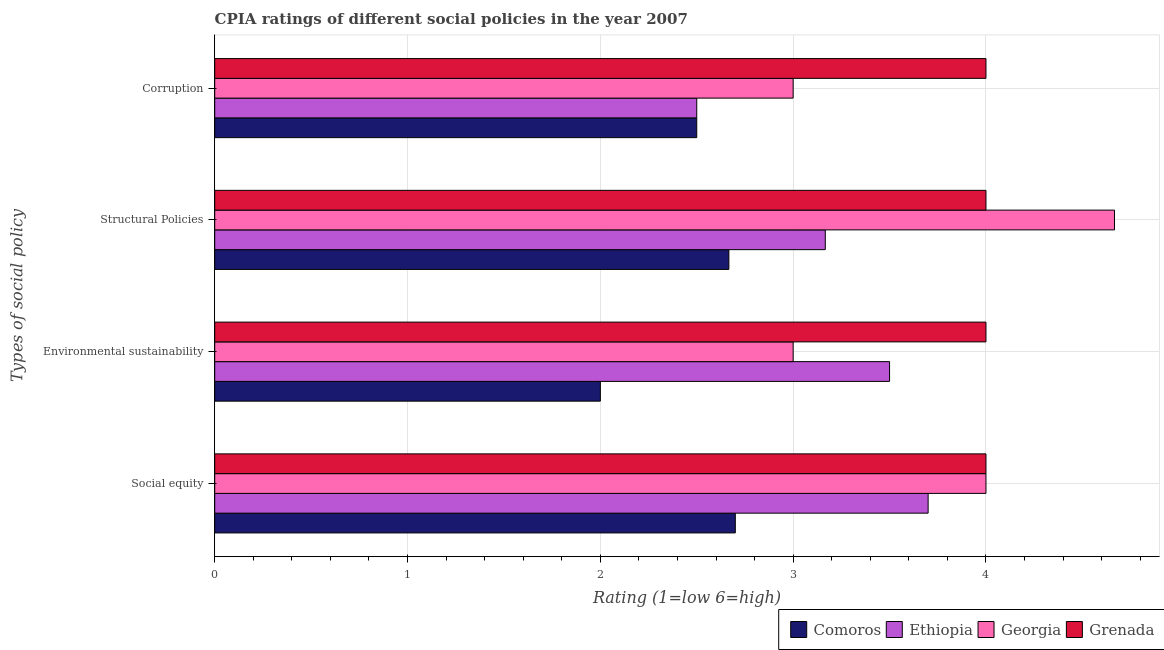How many groups of bars are there?
Ensure brevity in your answer.  4. Are the number of bars per tick equal to the number of legend labels?
Your answer should be very brief. Yes. Are the number of bars on each tick of the Y-axis equal?
Keep it short and to the point. Yes. What is the label of the 2nd group of bars from the top?
Keep it short and to the point. Structural Policies. What is the cpia rating of environmental sustainability in Georgia?
Your answer should be compact. 3. Across all countries, what is the maximum cpia rating of structural policies?
Give a very brief answer. 4.67. Across all countries, what is the minimum cpia rating of social equity?
Offer a very short reply. 2.7. In which country was the cpia rating of environmental sustainability maximum?
Provide a succinct answer. Grenada. In which country was the cpia rating of social equity minimum?
Provide a succinct answer. Comoros. What is the total cpia rating of corruption in the graph?
Ensure brevity in your answer.  12. What is the difference between the cpia rating of corruption in Comoros and the cpia rating of social equity in Georgia?
Your answer should be very brief. -1.5. What is the average cpia rating of social equity per country?
Offer a terse response. 3.6. What is the difference between the cpia rating of social equity and cpia rating of corruption in Comoros?
Give a very brief answer. 0.2. What is the ratio of the cpia rating of environmental sustainability in Grenada to that in Ethiopia?
Keep it short and to the point. 1.14. Is the cpia rating of corruption in Georgia less than that in Grenada?
Your response must be concise. Yes. Is the difference between the cpia rating of structural policies in Georgia and Ethiopia greater than the difference between the cpia rating of corruption in Georgia and Ethiopia?
Your answer should be compact. Yes. What is the difference between the highest and the second highest cpia rating of corruption?
Your answer should be compact. 1. What is the difference between the highest and the lowest cpia rating of environmental sustainability?
Provide a short and direct response. 2. Is the sum of the cpia rating of environmental sustainability in Grenada and Ethiopia greater than the maximum cpia rating of corruption across all countries?
Make the answer very short. Yes. Is it the case that in every country, the sum of the cpia rating of structural policies and cpia rating of corruption is greater than the sum of cpia rating of environmental sustainability and cpia rating of social equity?
Offer a very short reply. No. What does the 1st bar from the top in Corruption represents?
Offer a terse response. Grenada. What does the 1st bar from the bottom in Corruption represents?
Your response must be concise. Comoros. Is it the case that in every country, the sum of the cpia rating of social equity and cpia rating of environmental sustainability is greater than the cpia rating of structural policies?
Your answer should be compact. Yes. How many bars are there?
Offer a terse response. 16. How many countries are there in the graph?
Provide a succinct answer. 4. Are the values on the major ticks of X-axis written in scientific E-notation?
Your answer should be very brief. No. Does the graph contain grids?
Make the answer very short. Yes. Where does the legend appear in the graph?
Keep it short and to the point. Bottom right. How are the legend labels stacked?
Your answer should be very brief. Horizontal. What is the title of the graph?
Your answer should be compact. CPIA ratings of different social policies in the year 2007. What is the label or title of the Y-axis?
Provide a short and direct response. Types of social policy. What is the Rating (1=low 6=high) in Comoros in Social equity?
Ensure brevity in your answer.  2.7. What is the Rating (1=low 6=high) of Grenada in Social equity?
Provide a succinct answer. 4. What is the Rating (1=low 6=high) of Comoros in Environmental sustainability?
Give a very brief answer. 2. What is the Rating (1=low 6=high) in Comoros in Structural Policies?
Offer a very short reply. 2.67. What is the Rating (1=low 6=high) of Ethiopia in Structural Policies?
Give a very brief answer. 3.17. What is the Rating (1=low 6=high) in Georgia in Structural Policies?
Ensure brevity in your answer.  4.67. What is the Rating (1=low 6=high) of Grenada in Structural Policies?
Keep it short and to the point. 4. What is the Rating (1=low 6=high) in Comoros in Corruption?
Your answer should be compact. 2.5. What is the Rating (1=low 6=high) of Grenada in Corruption?
Make the answer very short. 4. Across all Types of social policy, what is the maximum Rating (1=low 6=high) in Comoros?
Offer a very short reply. 2.7. Across all Types of social policy, what is the maximum Rating (1=low 6=high) in Georgia?
Provide a succinct answer. 4.67. Across all Types of social policy, what is the minimum Rating (1=low 6=high) of Ethiopia?
Your response must be concise. 2.5. Across all Types of social policy, what is the minimum Rating (1=low 6=high) in Grenada?
Your answer should be very brief. 4. What is the total Rating (1=low 6=high) in Comoros in the graph?
Your answer should be very brief. 9.87. What is the total Rating (1=low 6=high) in Ethiopia in the graph?
Give a very brief answer. 12.87. What is the total Rating (1=low 6=high) in Georgia in the graph?
Ensure brevity in your answer.  14.67. What is the total Rating (1=low 6=high) of Grenada in the graph?
Your response must be concise. 16. What is the difference between the Rating (1=low 6=high) of Comoros in Social equity and that in Environmental sustainability?
Keep it short and to the point. 0.7. What is the difference between the Rating (1=low 6=high) of Grenada in Social equity and that in Environmental sustainability?
Your response must be concise. 0. What is the difference between the Rating (1=low 6=high) in Comoros in Social equity and that in Structural Policies?
Your answer should be compact. 0.03. What is the difference between the Rating (1=low 6=high) in Ethiopia in Social equity and that in Structural Policies?
Your answer should be very brief. 0.53. What is the difference between the Rating (1=low 6=high) in Georgia in Social equity and that in Structural Policies?
Make the answer very short. -0.67. What is the difference between the Rating (1=low 6=high) in Grenada in Social equity and that in Structural Policies?
Your answer should be compact. 0. What is the difference between the Rating (1=low 6=high) of Ethiopia in Social equity and that in Corruption?
Ensure brevity in your answer.  1.2. What is the difference between the Rating (1=low 6=high) of Georgia in Social equity and that in Corruption?
Give a very brief answer. 1. What is the difference between the Rating (1=low 6=high) in Georgia in Environmental sustainability and that in Structural Policies?
Your answer should be very brief. -1.67. What is the difference between the Rating (1=low 6=high) in Comoros in Environmental sustainability and that in Corruption?
Provide a succinct answer. -0.5. What is the difference between the Rating (1=low 6=high) in Ethiopia in Environmental sustainability and that in Corruption?
Your response must be concise. 1. What is the difference between the Rating (1=low 6=high) of Grenada in Environmental sustainability and that in Corruption?
Your answer should be very brief. 0. What is the difference between the Rating (1=low 6=high) of Comoros in Social equity and the Rating (1=low 6=high) of Ethiopia in Environmental sustainability?
Your response must be concise. -0.8. What is the difference between the Rating (1=low 6=high) in Comoros in Social equity and the Rating (1=low 6=high) in Grenada in Environmental sustainability?
Make the answer very short. -1.3. What is the difference between the Rating (1=low 6=high) in Ethiopia in Social equity and the Rating (1=low 6=high) in Georgia in Environmental sustainability?
Offer a very short reply. 0.7. What is the difference between the Rating (1=low 6=high) of Ethiopia in Social equity and the Rating (1=low 6=high) of Grenada in Environmental sustainability?
Your response must be concise. -0.3. What is the difference between the Rating (1=low 6=high) in Comoros in Social equity and the Rating (1=low 6=high) in Ethiopia in Structural Policies?
Provide a succinct answer. -0.47. What is the difference between the Rating (1=low 6=high) of Comoros in Social equity and the Rating (1=low 6=high) of Georgia in Structural Policies?
Make the answer very short. -1.97. What is the difference between the Rating (1=low 6=high) of Ethiopia in Social equity and the Rating (1=low 6=high) of Georgia in Structural Policies?
Ensure brevity in your answer.  -0.97. What is the difference between the Rating (1=low 6=high) in Georgia in Social equity and the Rating (1=low 6=high) in Grenada in Structural Policies?
Your answer should be compact. 0. What is the difference between the Rating (1=low 6=high) in Comoros in Social equity and the Rating (1=low 6=high) in Ethiopia in Corruption?
Give a very brief answer. 0.2. What is the difference between the Rating (1=low 6=high) in Comoros in Social equity and the Rating (1=low 6=high) in Georgia in Corruption?
Offer a very short reply. -0.3. What is the difference between the Rating (1=low 6=high) of Georgia in Social equity and the Rating (1=low 6=high) of Grenada in Corruption?
Your answer should be very brief. 0. What is the difference between the Rating (1=low 6=high) in Comoros in Environmental sustainability and the Rating (1=low 6=high) in Ethiopia in Structural Policies?
Provide a short and direct response. -1.17. What is the difference between the Rating (1=low 6=high) in Comoros in Environmental sustainability and the Rating (1=low 6=high) in Georgia in Structural Policies?
Make the answer very short. -2.67. What is the difference between the Rating (1=low 6=high) of Comoros in Environmental sustainability and the Rating (1=low 6=high) of Grenada in Structural Policies?
Offer a terse response. -2. What is the difference between the Rating (1=low 6=high) of Ethiopia in Environmental sustainability and the Rating (1=low 6=high) of Georgia in Structural Policies?
Give a very brief answer. -1.17. What is the difference between the Rating (1=low 6=high) of Ethiopia in Environmental sustainability and the Rating (1=low 6=high) of Grenada in Structural Policies?
Provide a short and direct response. -0.5. What is the difference between the Rating (1=low 6=high) in Georgia in Environmental sustainability and the Rating (1=low 6=high) in Grenada in Structural Policies?
Make the answer very short. -1. What is the difference between the Rating (1=low 6=high) of Ethiopia in Environmental sustainability and the Rating (1=low 6=high) of Grenada in Corruption?
Offer a very short reply. -0.5. What is the difference between the Rating (1=low 6=high) of Georgia in Environmental sustainability and the Rating (1=low 6=high) of Grenada in Corruption?
Give a very brief answer. -1. What is the difference between the Rating (1=low 6=high) in Comoros in Structural Policies and the Rating (1=low 6=high) in Grenada in Corruption?
Ensure brevity in your answer.  -1.33. What is the difference between the Rating (1=low 6=high) in Ethiopia in Structural Policies and the Rating (1=low 6=high) in Georgia in Corruption?
Your answer should be compact. 0.17. What is the average Rating (1=low 6=high) of Comoros per Types of social policy?
Offer a terse response. 2.47. What is the average Rating (1=low 6=high) in Ethiopia per Types of social policy?
Provide a succinct answer. 3.22. What is the average Rating (1=low 6=high) of Georgia per Types of social policy?
Provide a succinct answer. 3.67. What is the difference between the Rating (1=low 6=high) in Comoros and Rating (1=low 6=high) in Ethiopia in Social equity?
Give a very brief answer. -1. What is the difference between the Rating (1=low 6=high) in Comoros and Rating (1=low 6=high) in Grenada in Social equity?
Offer a very short reply. -1.3. What is the difference between the Rating (1=low 6=high) in Ethiopia and Rating (1=low 6=high) in Grenada in Social equity?
Your answer should be compact. -0.3. What is the difference between the Rating (1=low 6=high) of Georgia and Rating (1=low 6=high) of Grenada in Social equity?
Give a very brief answer. 0. What is the difference between the Rating (1=low 6=high) of Comoros and Rating (1=low 6=high) of Ethiopia in Environmental sustainability?
Your response must be concise. -1.5. What is the difference between the Rating (1=low 6=high) of Comoros and Rating (1=low 6=high) of Grenada in Environmental sustainability?
Your answer should be very brief. -2. What is the difference between the Rating (1=low 6=high) of Ethiopia and Rating (1=low 6=high) of Georgia in Environmental sustainability?
Ensure brevity in your answer.  0.5. What is the difference between the Rating (1=low 6=high) of Ethiopia and Rating (1=low 6=high) of Grenada in Environmental sustainability?
Make the answer very short. -0.5. What is the difference between the Rating (1=low 6=high) of Georgia and Rating (1=low 6=high) of Grenada in Environmental sustainability?
Give a very brief answer. -1. What is the difference between the Rating (1=low 6=high) in Comoros and Rating (1=low 6=high) in Grenada in Structural Policies?
Offer a very short reply. -1.33. What is the difference between the Rating (1=low 6=high) in Ethiopia and Rating (1=low 6=high) in Georgia in Structural Policies?
Ensure brevity in your answer.  -1.5. What is the difference between the Rating (1=low 6=high) in Ethiopia and Rating (1=low 6=high) in Grenada in Structural Policies?
Your response must be concise. -0.83. What is the difference between the Rating (1=low 6=high) in Georgia and Rating (1=low 6=high) in Grenada in Structural Policies?
Keep it short and to the point. 0.67. What is the difference between the Rating (1=low 6=high) in Comoros and Rating (1=low 6=high) in Ethiopia in Corruption?
Offer a very short reply. 0. What is the difference between the Rating (1=low 6=high) in Comoros and Rating (1=low 6=high) in Georgia in Corruption?
Give a very brief answer. -0.5. What is the difference between the Rating (1=low 6=high) of Comoros and Rating (1=low 6=high) of Grenada in Corruption?
Give a very brief answer. -1.5. What is the difference between the Rating (1=low 6=high) in Ethiopia and Rating (1=low 6=high) in Georgia in Corruption?
Your answer should be compact. -0.5. What is the difference between the Rating (1=low 6=high) in Georgia and Rating (1=low 6=high) in Grenada in Corruption?
Offer a terse response. -1. What is the ratio of the Rating (1=low 6=high) in Comoros in Social equity to that in Environmental sustainability?
Your answer should be compact. 1.35. What is the ratio of the Rating (1=low 6=high) of Ethiopia in Social equity to that in Environmental sustainability?
Your response must be concise. 1.06. What is the ratio of the Rating (1=low 6=high) in Grenada in Social equity to that in Environmental sustainability?
Your answer should be compact. 1. What is the ratio of the Rating (1=low 6=high) of Comoros in Social equity to that in Structural Policies?
Your response must be concise. 1.01. What is the ratio of the Rating (1=low 6=high) of Ethiopia in Social equity to that in Structural Policies?
Provide a short and direct response. 1.17. What is the ratio of the Rating (1=low 6=high) of Grenada in Social equity to that in Structural Policies?
Provide a short and direct response. 1. What is the ratio of the Rating (1=low 6=high) in Comoros in Social equity to that in Corruption?
Ensure brevity in your answer.  1.08. What is the ratio of the Rating (1=low 6=high) of Ethiopia in Social equity to that in Corruption?
Keep it short and to the point. 1.48. What is the ratio of the Rating (1=low 6=high) in Ethiopia in Environmental sustainability to that in Structural Policies?
Provide a succinct answer. 1.11. What is the ratio of the Rating (1=low 6=high) in Georgia in Environmental sustainability to that in Structural Policies?
Provide a succinct answer. 0.64. What is the ratio of the Rating (1=low 6=high) of Grenada in Environmental sustainability to that in Structural Policies?
Your response must be concise. 1. What is the ratio of the Rating (1=low 6=high) of Comoros in Environmental sustainability to that in Corruption?
Offer a terse response. 0.8. What is the ratio of the Rating (1=low 6=high) in Ethiopia in Environmental sustainability to that in Corruption?
Keep it short and to the point. 1.4. What is the ratio of the Rating (1=low 6=high) of Georgia in Environmental sustainability to that in Corruption?
Ensure brevity in your answer.  1. What is the ratio of the Rating (1=low 6=high) of Grenada in Environmental sustainability to that in Corruption?
Provide a short and direct response. 1. What is the ratio of the Rating (1=low 6=high) of Comoros in Structural Policies to that in Corruption?
Offer a terse response. 1.07. What is the ratio of the Rating (1=low 6=high) of Ethiopia in Structural Policies to that in Corruption?
Your answer should be compact. 1.27. What is the ratio of the Rating (1=low 6=high) of Georgia in Structural Policies to that in Corruption?
Make the answer very short. 1.56. What is the ratio of the Rating (1=low 6=high) of Grenada in Structural Policies to that in Corruption?
Offer a terse response. 1. What is the difference between the highest and the second highest Rating (1=low 6=high) in Comoros?
Ensure brevity in your answer.  0.03. What is the difference between the highest and the second highest Rating (1=low 6=high) of Grenada?
Your response must be concise. 0. What is the difference between the highest and the lowest Rating (1=low 6=high) in Comoros?
Provide a short and direct response. 0.7. What is the difference between the highest and the lowest Rating (1=low 6=high) in Ethiopia?
Make the answer very short. 1.2. What is the difference between the highest and the lowest Rating (1=low 6=high) of Georgia?
Give a very brief answer. 1.67. 